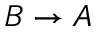<formula> <loc_0><loc_0><loc_500><loc_500>B \rightarrow A</formula> 